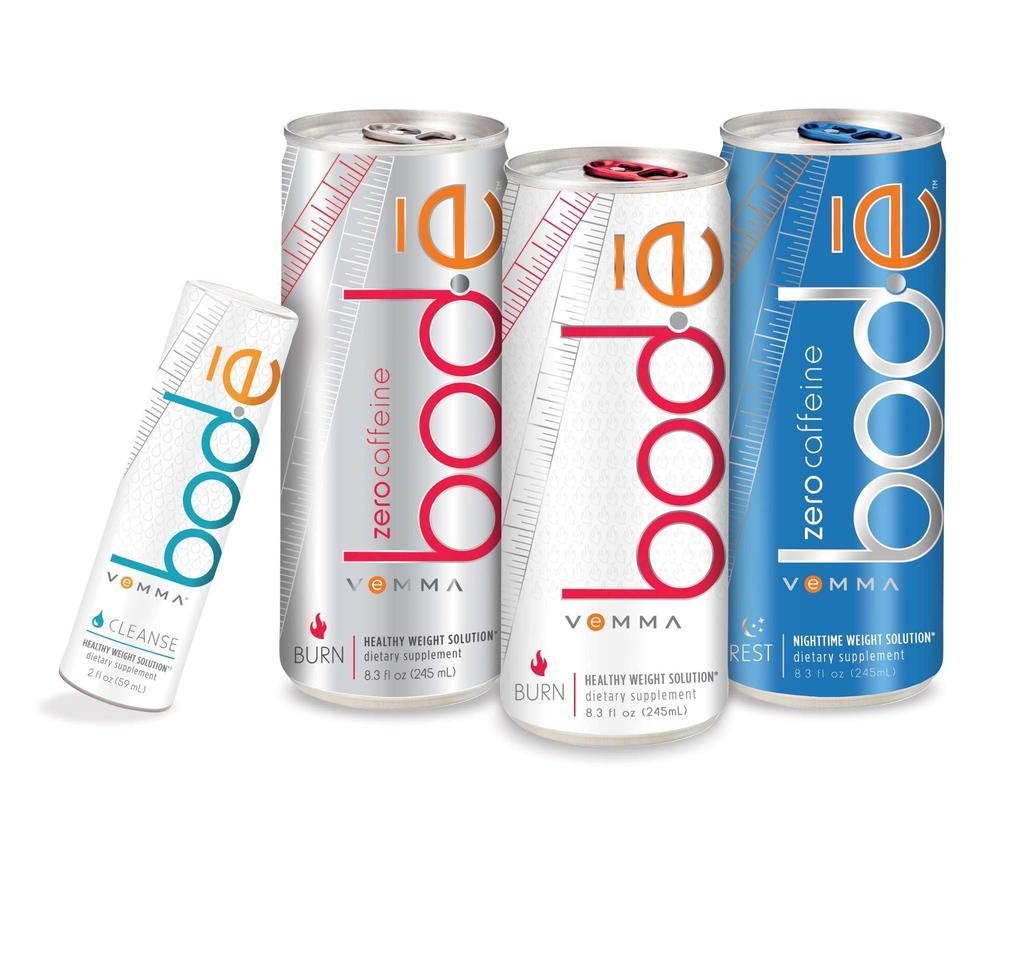<image>
Summarize the visual content of the image. A product shot of four cans of Bode dietary supplement drink. 